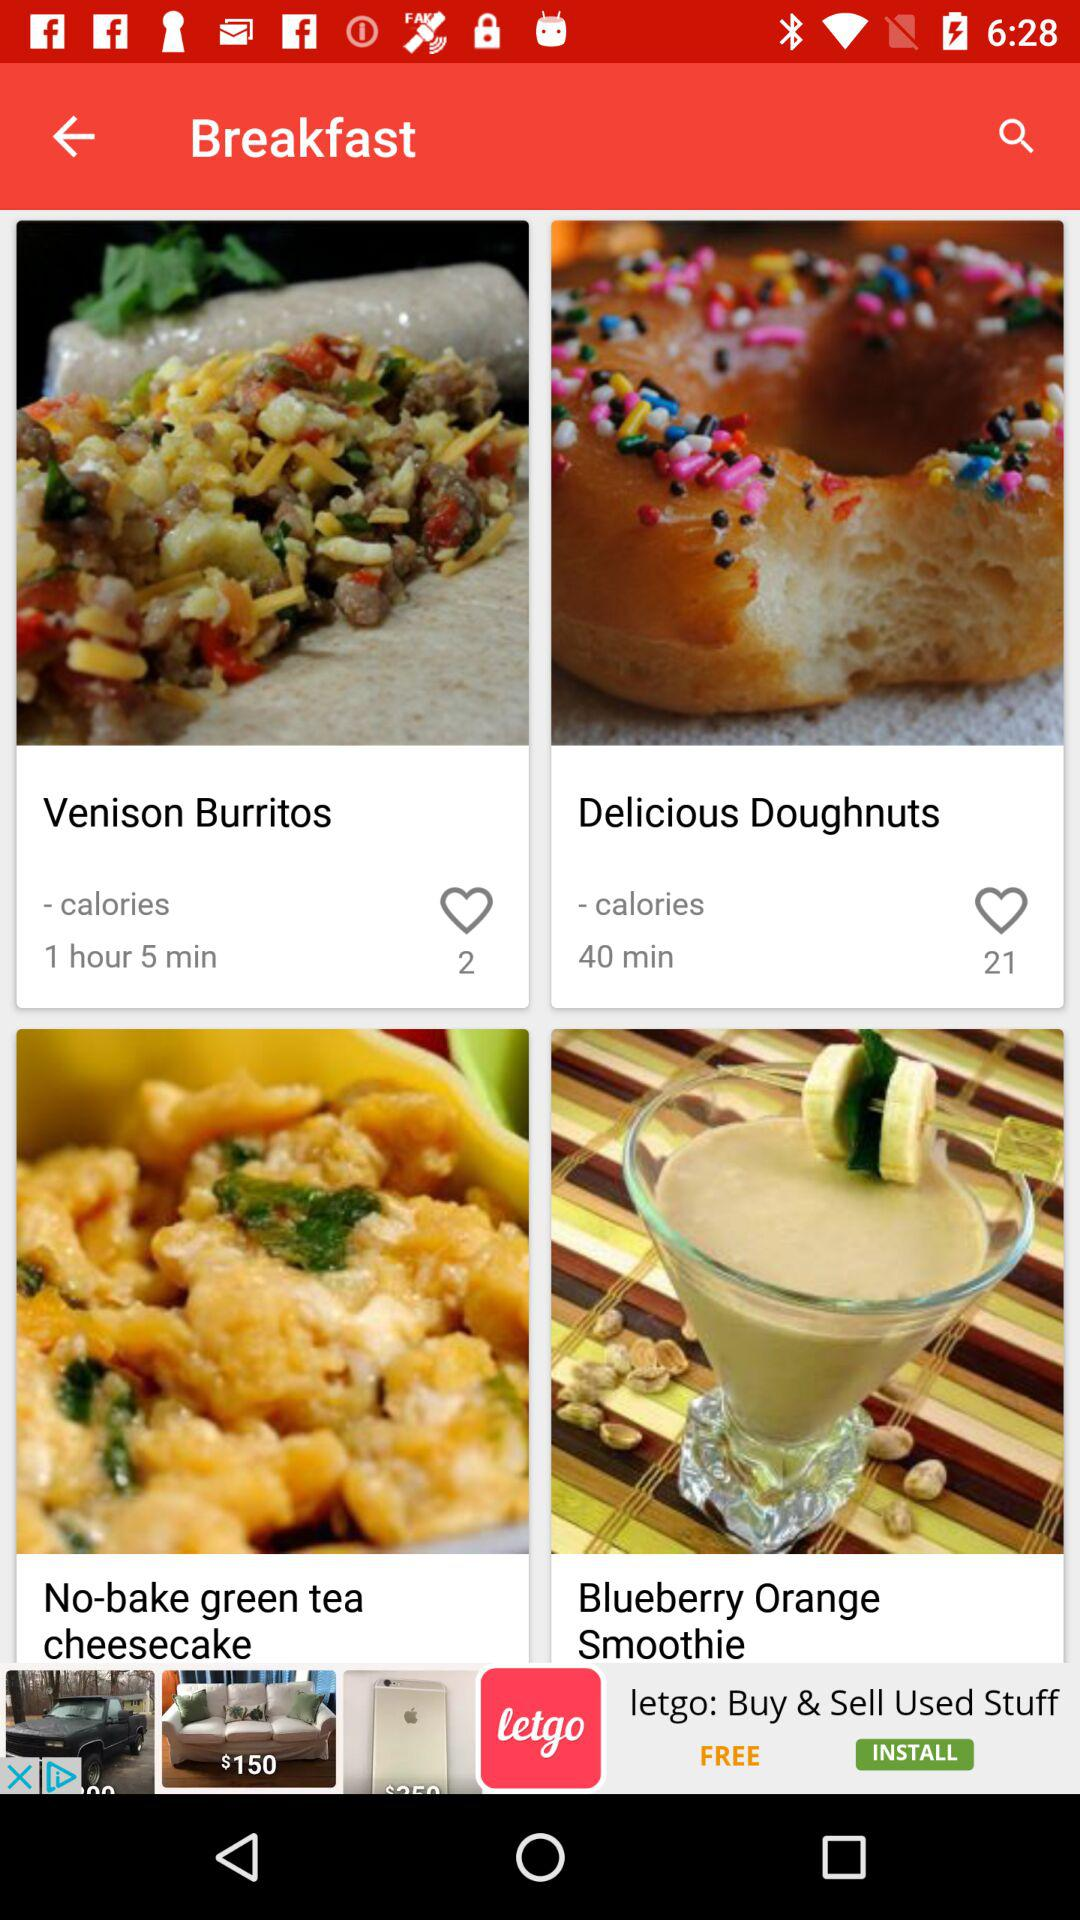What is the count of likes on delicious doughnuts? The count of likes on delicious doughnuts is 21. 